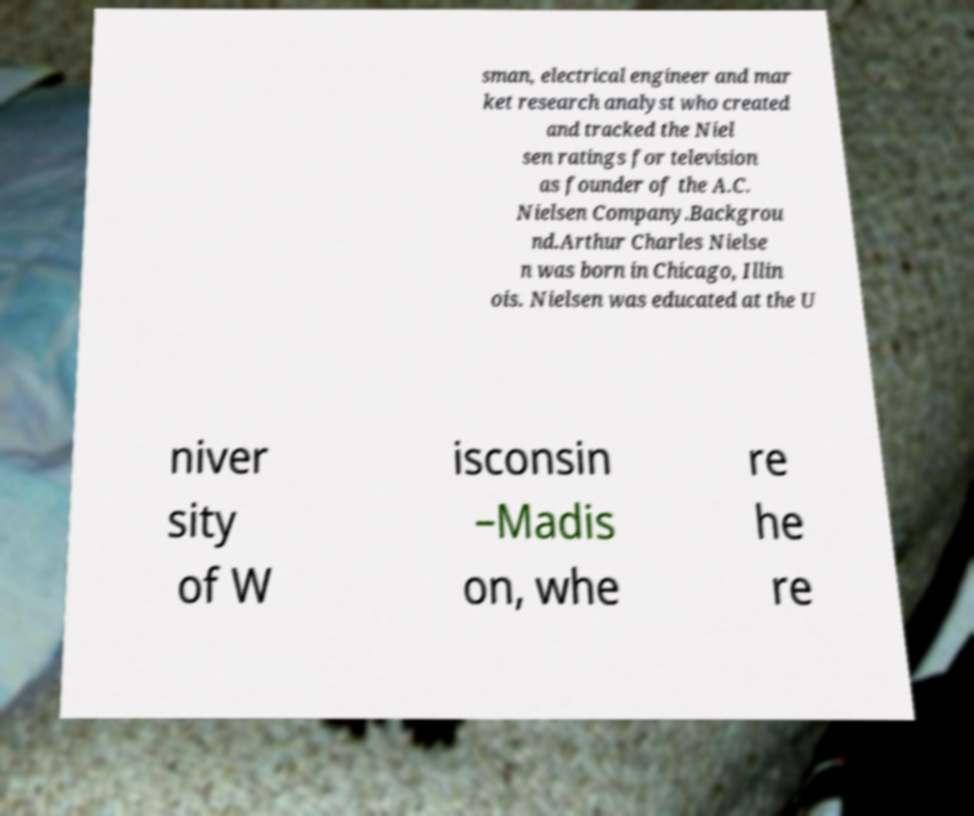Could you assist in decoding the text presented in this image and type it out clearly? sman, electrical engineer and mar ket research analyst who created and tracked the Niel sen ratings for television as founder of the A.C. Nielsen Company.Backgrou nd.Arthur Charles Nielse n was born in Chicago, Illin ois. Nielsen was educated at the U niver sity of W isconsin –Madis on, whe re he re 